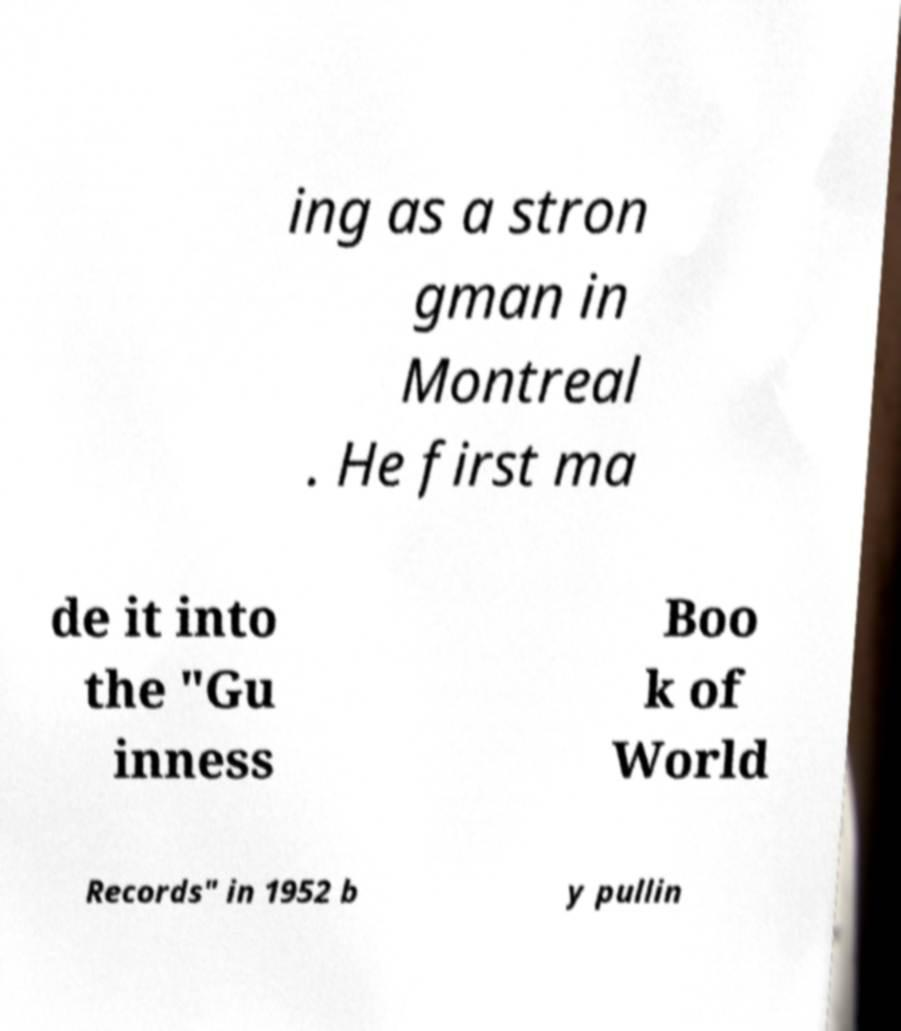Please read and relay the text visible in this image. What does it say? ing as a stron gman in Montreal . He first ma de it into the "Gu inness Boo k of World Records" in 1952 b y pullin 